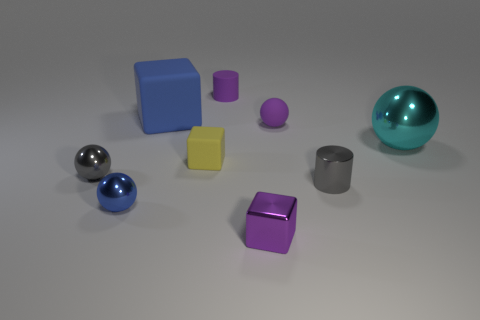What number of objects are either objects behind the rubber sphere or big green cylinders?
Provide a short and direct response. 2. What number of other things are there of the same material as the big sphere
Give a very brief answer. 4. There is a object that is the same color as the big matte block; what shape is it?
Your response must be concise. Sphere. There is a blue object on the right side of the blue metallic object; how big is it?
Offer a terse response. Large. There is a big object that is the same material as the blue sphere; what is its shape?
Give a very brief answer. Sphere. Is the material of the gray cylinder the same as the block behind the large ball?
Your answer should be very brief. No. Do the small purple matte object that is to the left of the small shiny block and the big rubber object have the same shape?
Offer a terse response. No. There is a tiny gray object that is the same shape as the large cyan thing; what is it made of?
Offer a very short reply. Metal. There is a large blue object; is it the same shape as the tiny purple rubber thing right of the rubber cylinder?
Provide a short and direct response. No. There is a thing that is in front of the tiny gray cylinder and on the left side of the big rubber thing; what color is it?
Your response must be concise. Blue. 